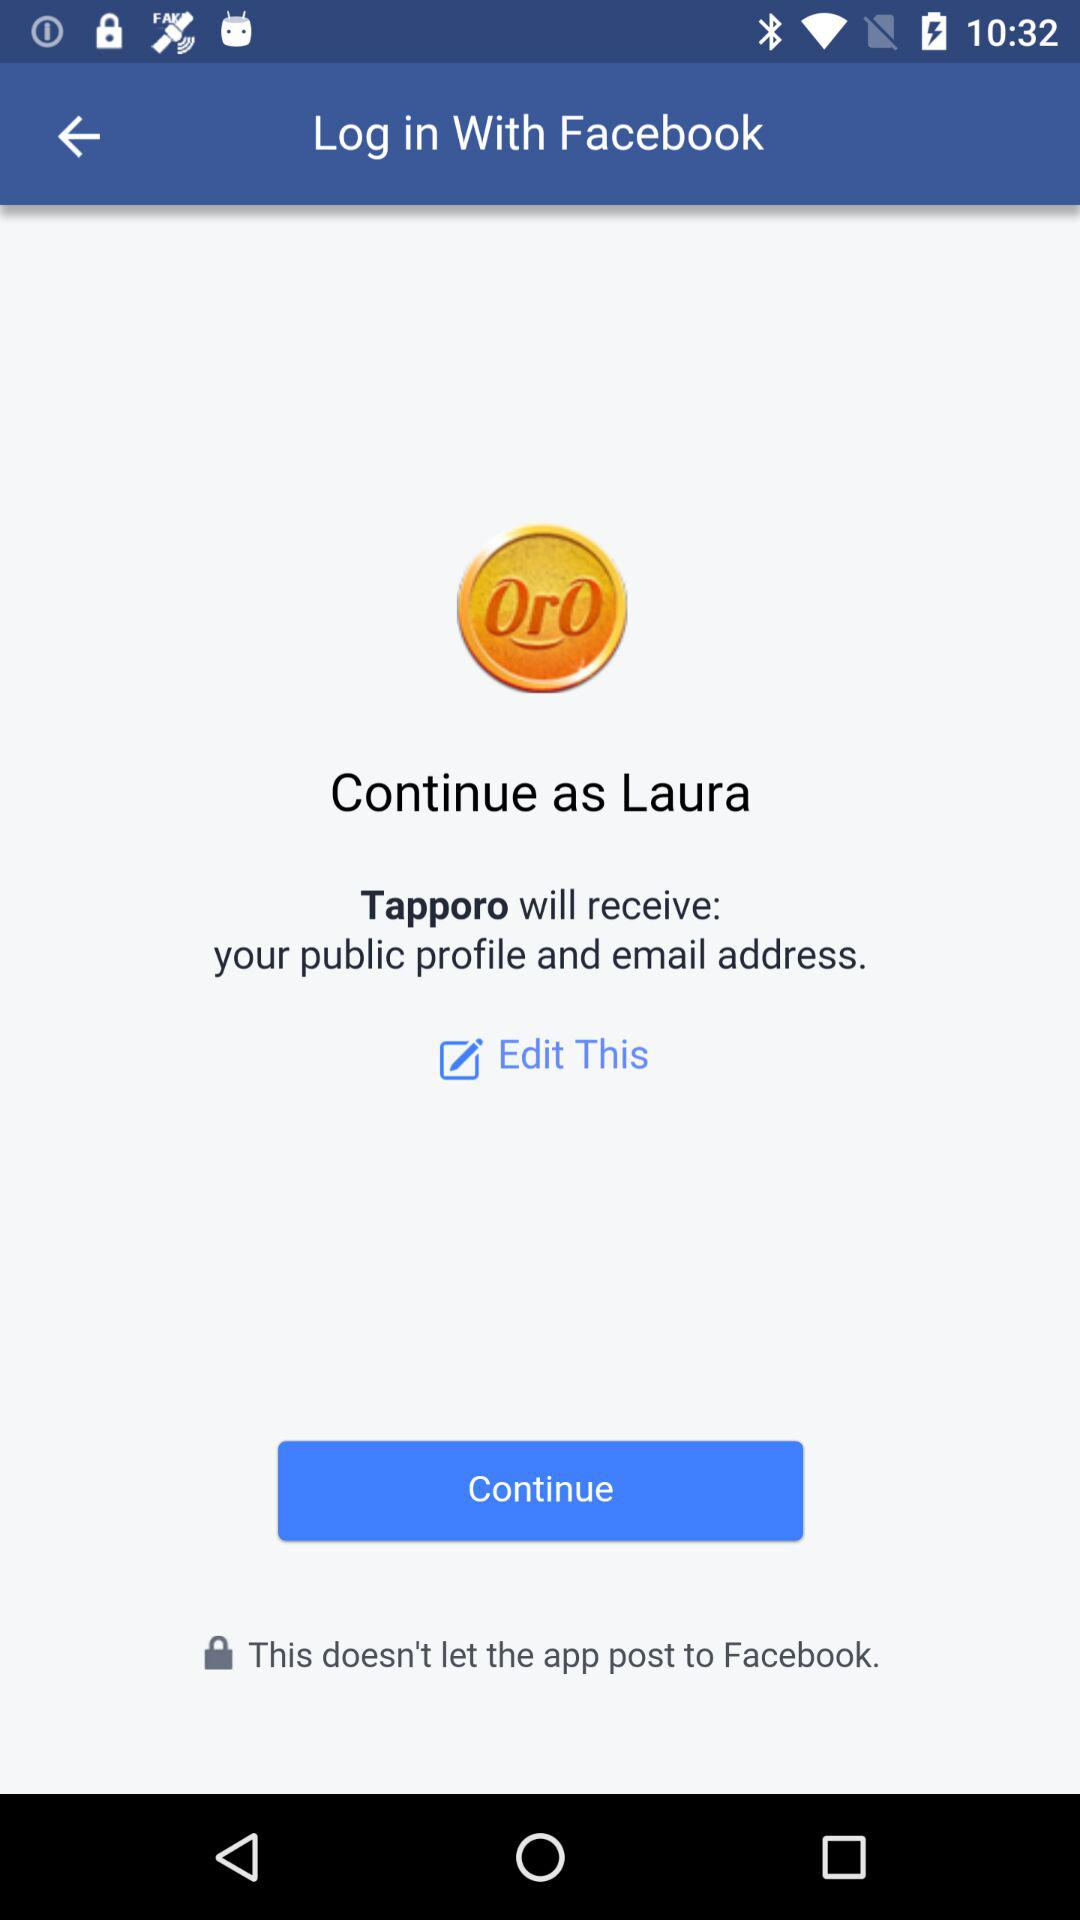What is the application to access? The application is "Tapporo". 